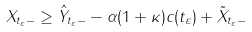Convert formula to latex. <formula><loc_0><loc_0><loc_500><loc_500>X _ { t _ { \varepsilon } - } \geq \hat { Y } _ { t _ { \varepsilon } - } - \alpha ( 1 + \kappa ) c ( t _ { \varepsilon } ) + \tilde { X } _ { t _ { \varepsilon } - }</formula> 